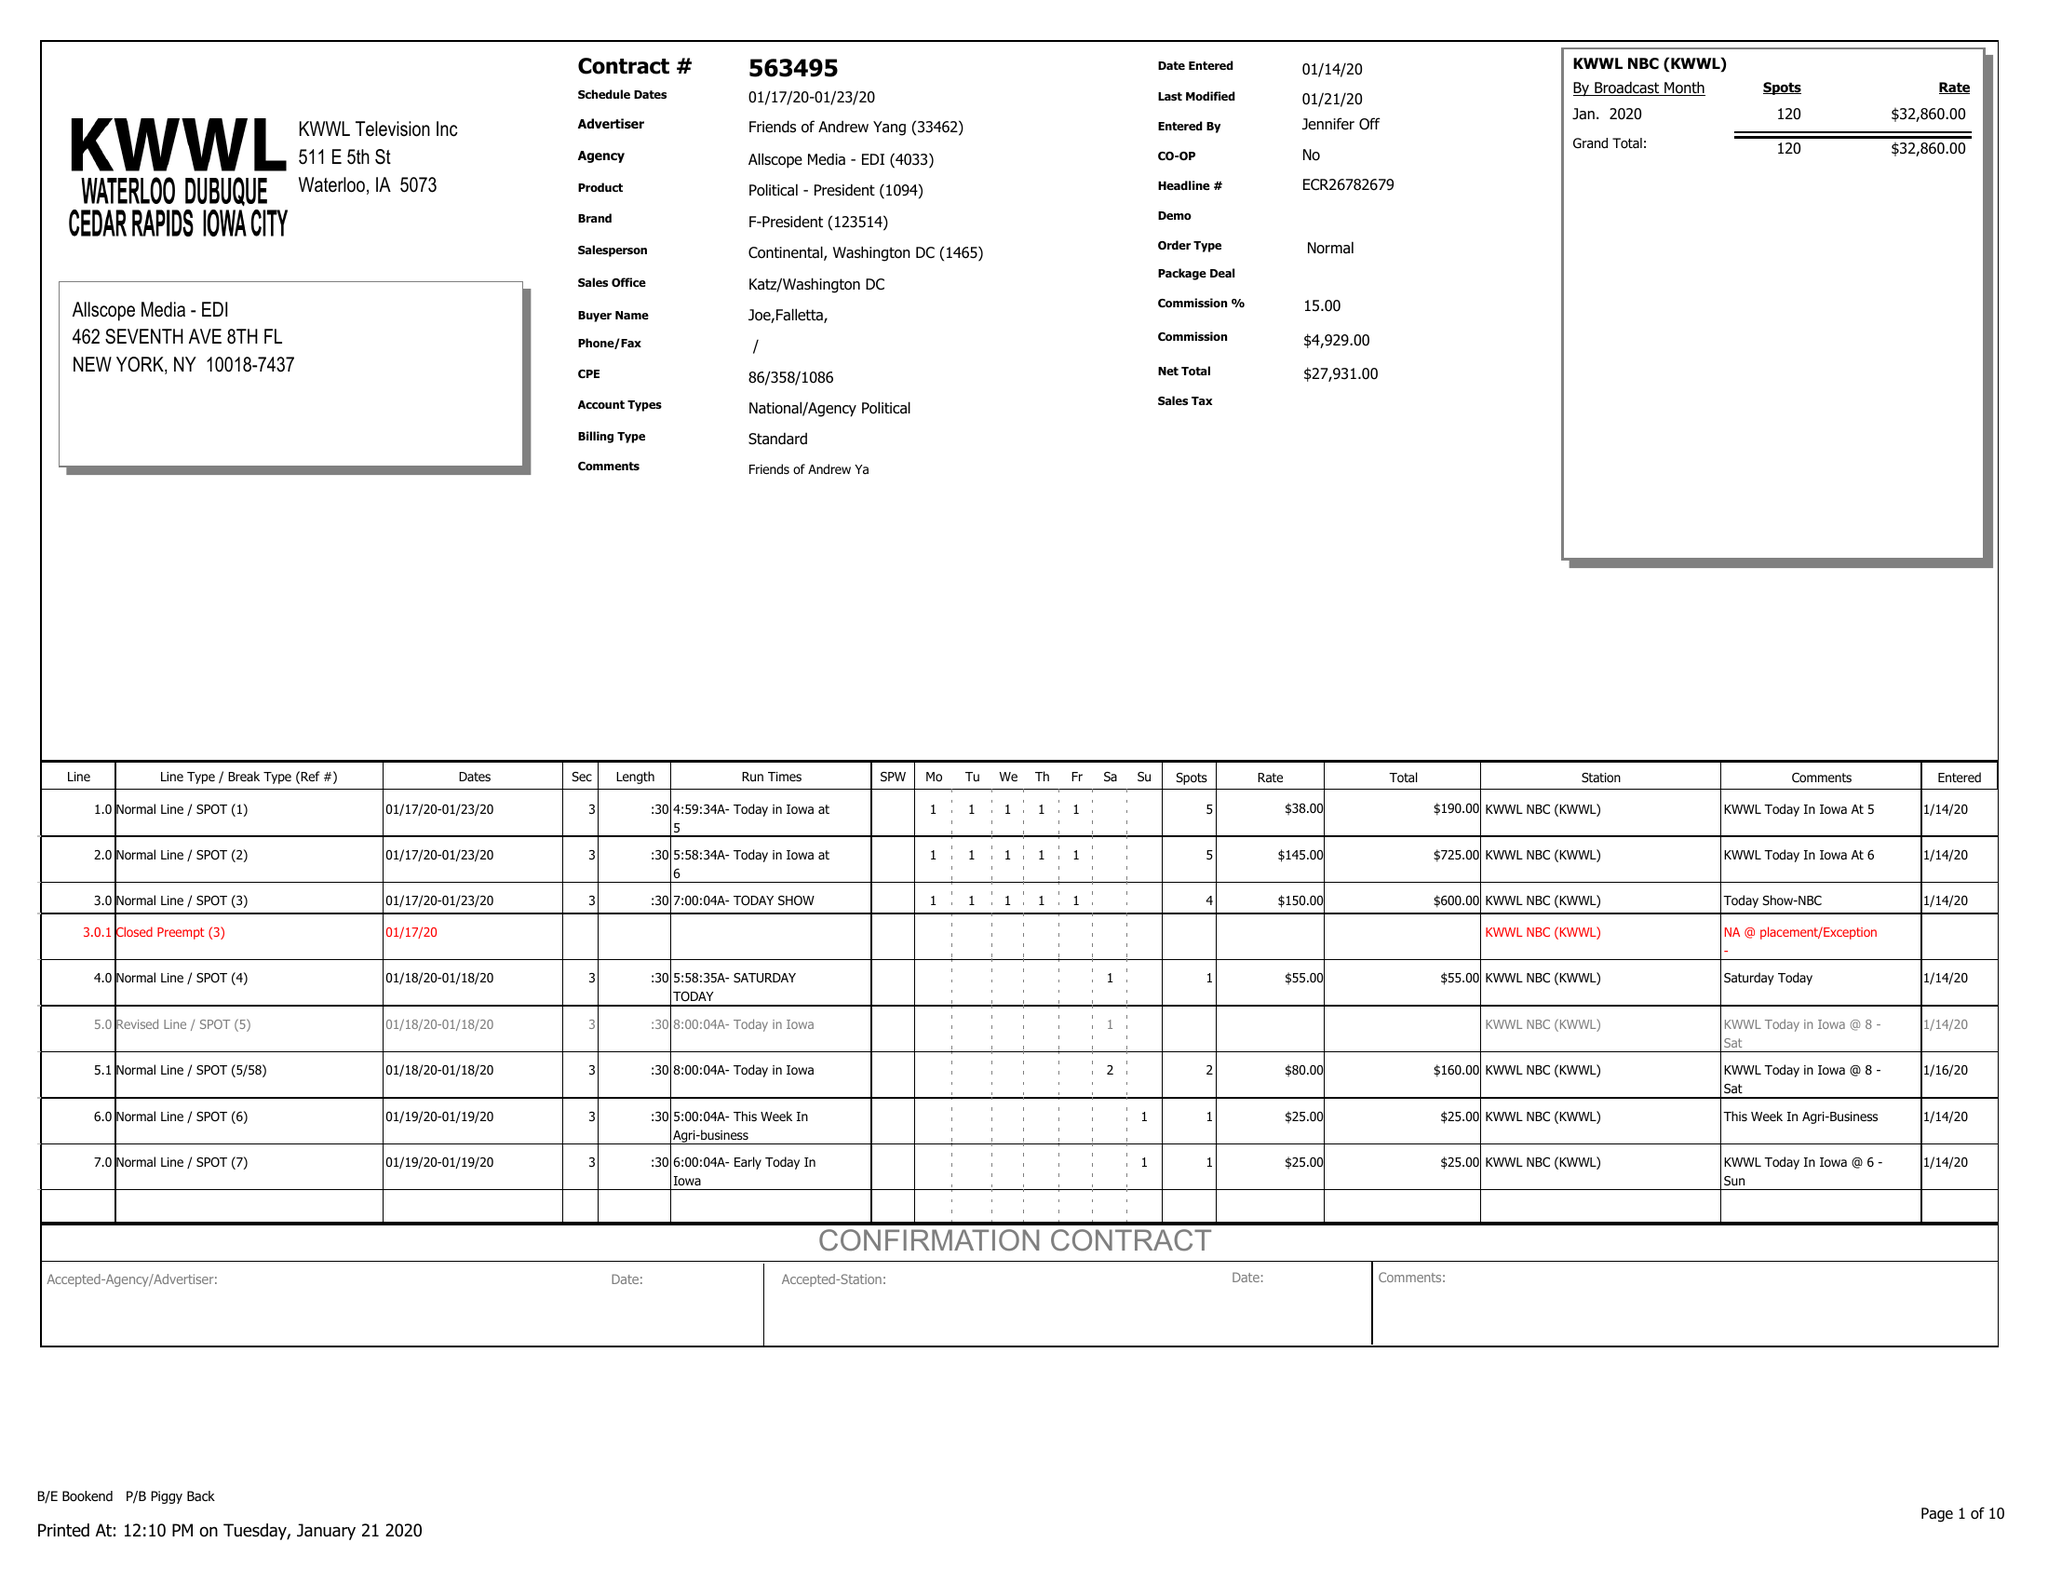What is the value for the gross_amount?
Answer the question using a single word or phrase. 32860.00 